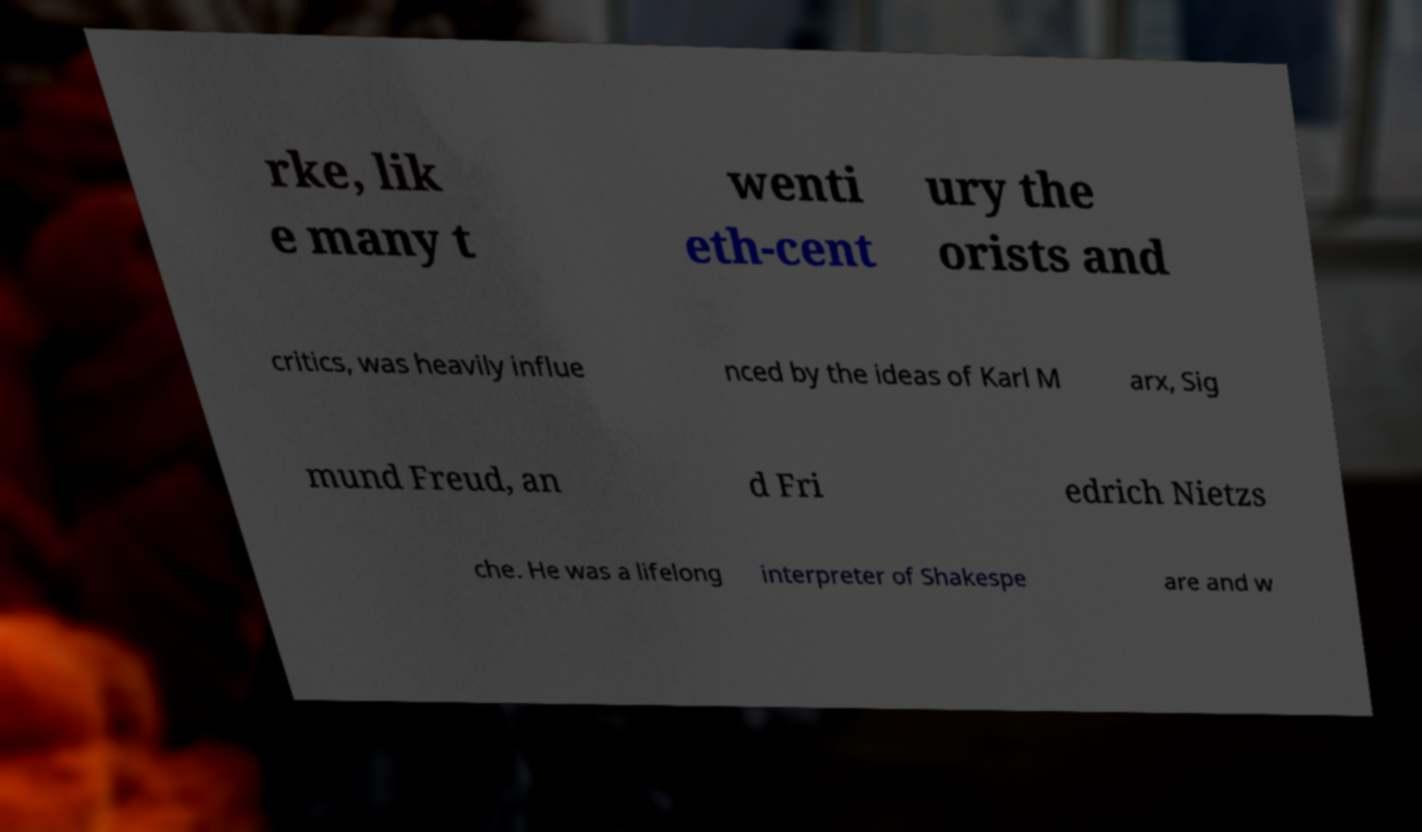Can you accurately transcribe the text from the provided image for me? rke, lik e many t wenti eth-cent ury the orists and critics, was heavily influe nced by the ideas of Karl M arx, Sig mund Freud, an d Fri edrich Nietzs che. He was a lifelong interpreter of Shakespe are and w 